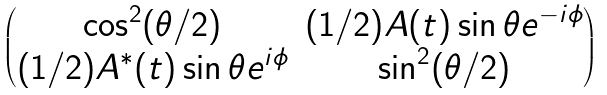<formula> <loc_0><loc_0><loc_500><loc_500>\begin{pmatrix} \cos ^ { 2 } ( \theta / 2 ) & ( 1 / 2 ) A ( t ) \sin \theta e ^ { - i \phi } \\ ( 1 / 2 ) A ^ { * } ( t ) \sin \theta e ^ { i \phi } & \sin ^ { 2 } ( \theta / 2 ) \end{pmatrix}</formula> 